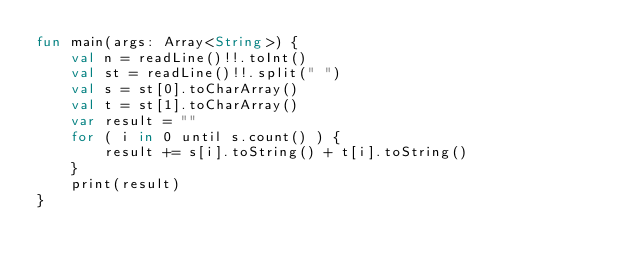Convert code to text. <code><loc_0><loc_0><loc_500><loc_500><_Kotlin_>fun main(args: Array<String>) {
    val n = readLine()!!.toInt()
    val st = readLine()!!.split(" ")
    val s = st[0].toCharArray()
    val t = st[1].toCharArray()
    var result = ""
    for ( i in 0 until s.count() ) {
        result += s[i].toString() + t[i].toString()
    }
    print(result)
}</code> 